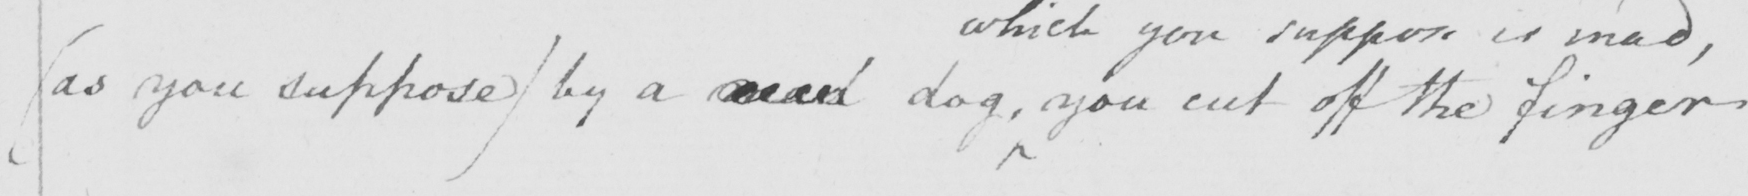Can you read and transcribe this handwriting? ( as you suppose )  by a mad dog , you cut off the finger 